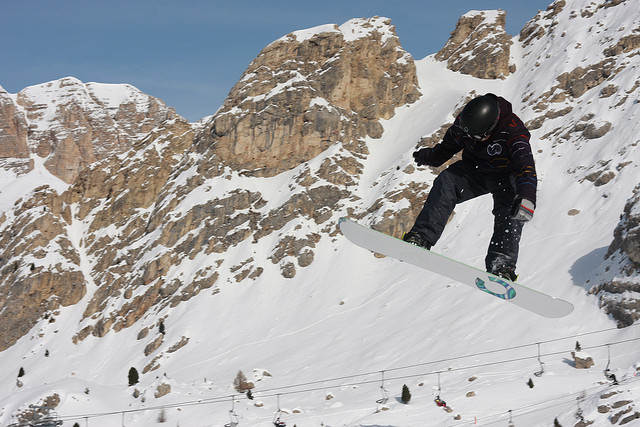If I were to visit such a location, what precautions or preparations should I consider? If you were to visit a similar snowy and mountainous location, you should consider the following precautions and preparations:
1. **Gear:** Wear appropriate winter sports gear, including a helmet, goggles, gloves, and thermal clothing.
2. **Safety Equipment:** Use snowboarding-specific safety equipment like wrist guards, knee pads, and avalanche transceivers.
3. **Physical Fitness:** Ensure you are physically fit and adequately trained for snowboarding in challenging terrains.
4. **Weather Check:** Always check the weather forecast and avalanche warnings before heading out.
5. **Buddy System:** Snowboard with a friend or in a group for safety.
6. **Local Guidance:** Hire a local guide or take lessons if you are not familiar with the area.
7. **Emergency Plan:** Have an emergency plan and know the location of the nearest medical facilities.
By taking these precautions, you can ensure a safer and more enjoyable experience. 